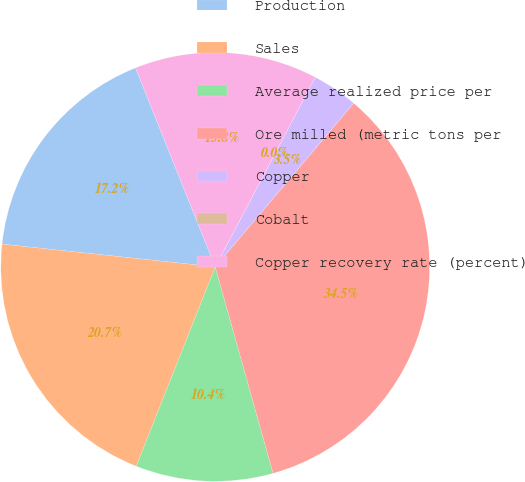<chart> <loc_0><loc_0><loc_500><loc_500><pie_chart><fcel>Production<fcel>Sales<fcel>Average realized price per<fcel>Ore milled (metric tons per<fcel>Copper<fcel>Cobalt<fcel>Copper recovery rate (percent)<nl><fcel>17.24%<fcel>20.69%<fcel>10.35%<fcel>34.48%<fcel>3.45%<fcel>0.0%<fcel>13.79%<nl></chart> 